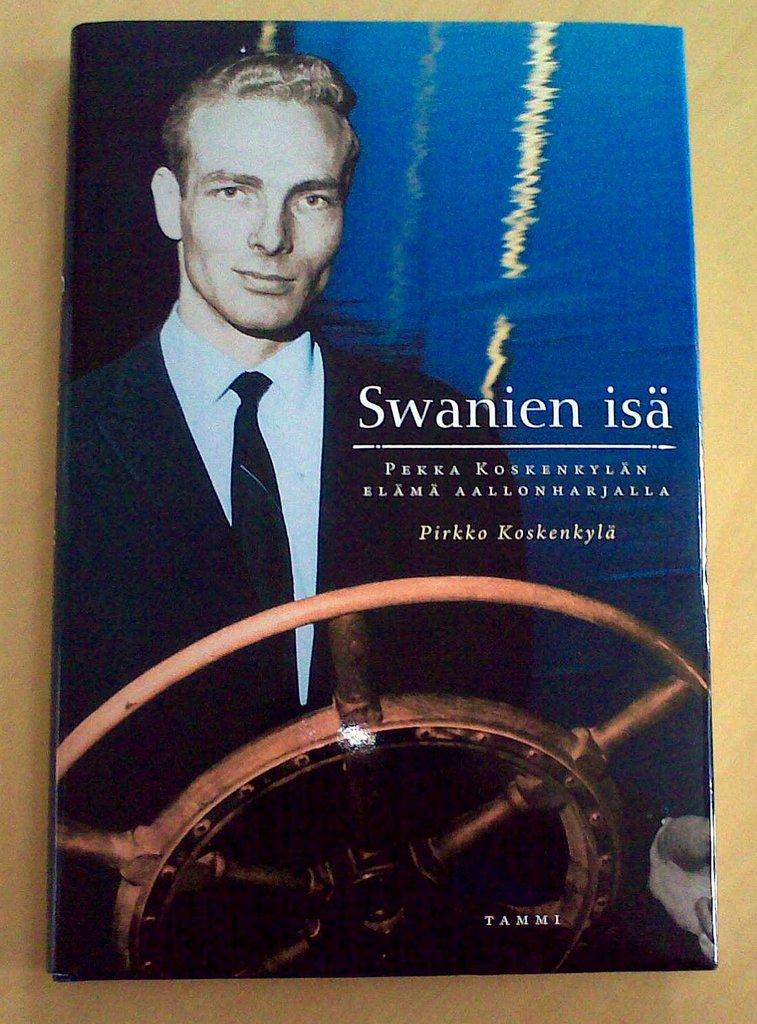<image>
Render a clear and concise summary of the photo. A book with a man in front of a ship steering wheel is called Swanien isa 